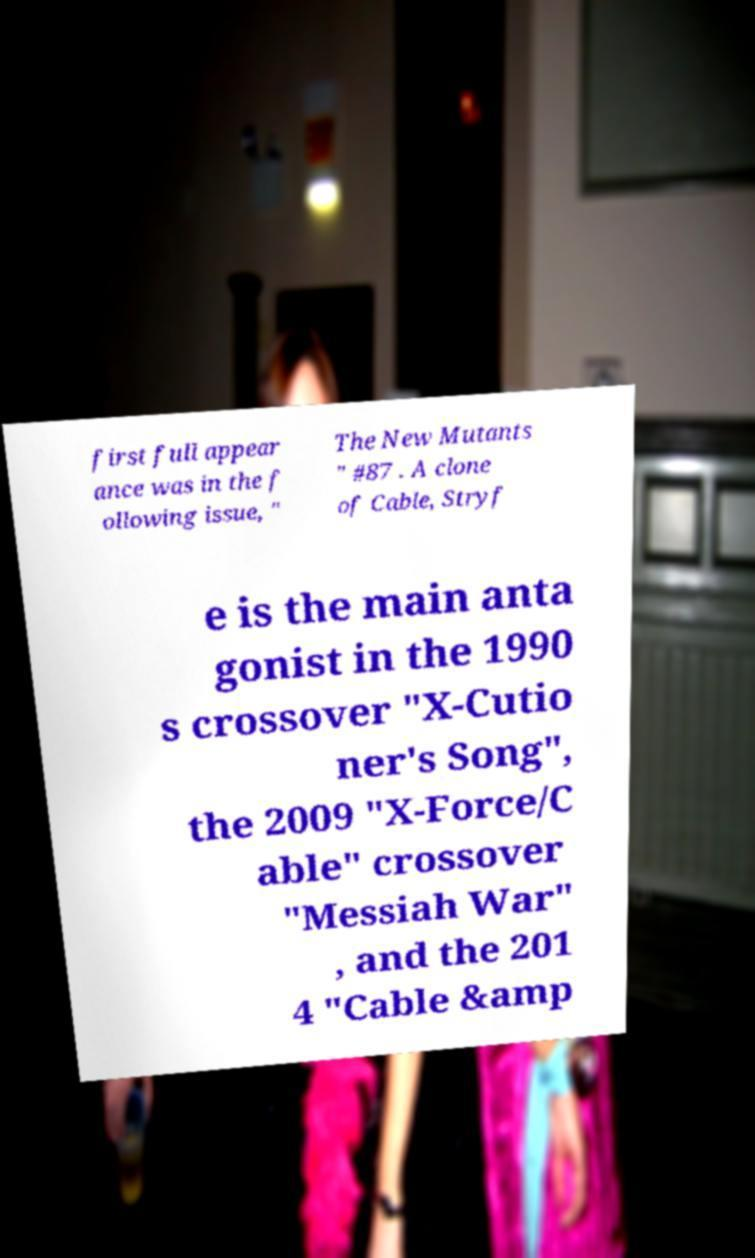What messages or text are displayed in this image? I need them in a readable, typed format. first full appear ance was in the f ollowing issue, " The New Mutants " #87 . A clone of Cable, Stryf e is the main anta gonist in the 1990 s crossover "X-Cutio ner's Song", the 2009 "X-Force/C able" crossover "Messiah War" , and the 201 4 "Cable &amp 